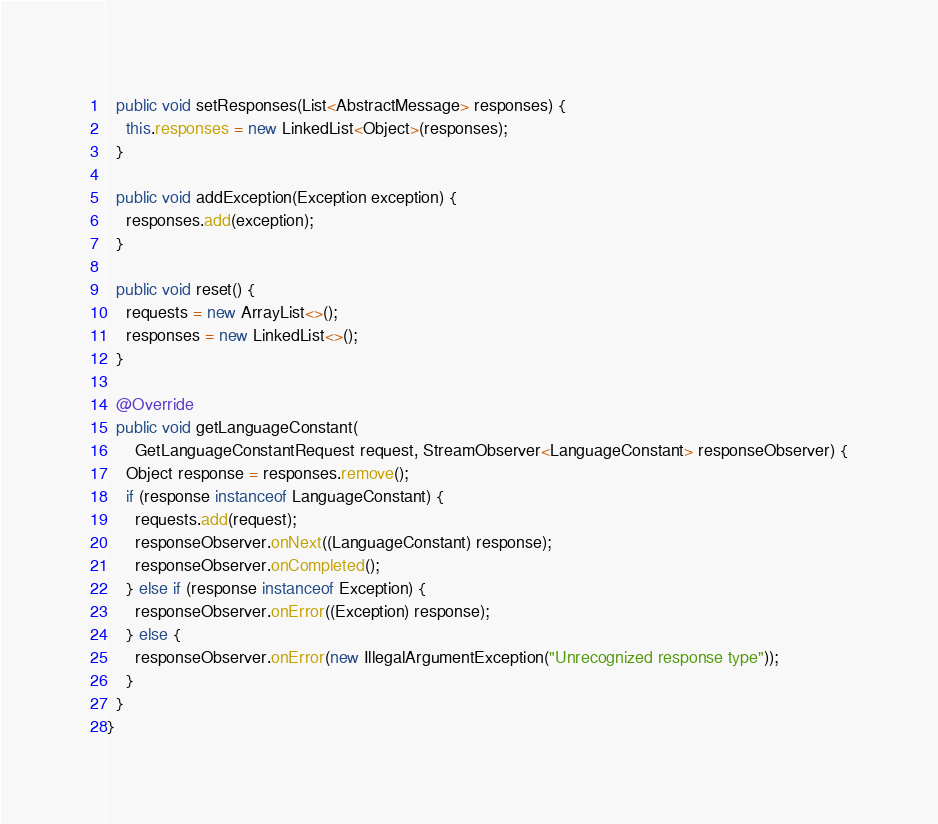Convert code to text. <code><loc_0><loc_0><loc_500><loc_500><_Java_>
  public void setResponses(List<AbstractMessage> responses) {
    this.responses = new LinkedList<Object>(responses);
  }

  public void addException(Exception exception) {
    responses.add(exception);
  }

  public void reset() {
    requests = new ArrayList<>();
    responses = new LinkedList<>();
  }

  @Override
  public void getLanguageConstant(
      GetLanguageConstantRequest request, StreamObserver<LanguageConstant> responseObserver) {
    Object response = responses.remove();
    if (response instanceof LanguageConstant) {
      requests.add(request);
      responseObserver.onNext((LanguageConstant) response);
      responseObserver.onCompleted();
    } else if (response instanceof Exception) {
      responseObserver.onError((Exception) response);
    } else {
      responseObserver.onError(new IllegalArgumentException("Unrecognized response type"));
    }
  }
}
</code> 